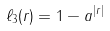Convert formula to latex. <formula><loc_0><loc_0><loc_500><loc_500>\ell _ { 3 } ( r ) = 1 - a ^ { | r | }</formula> 